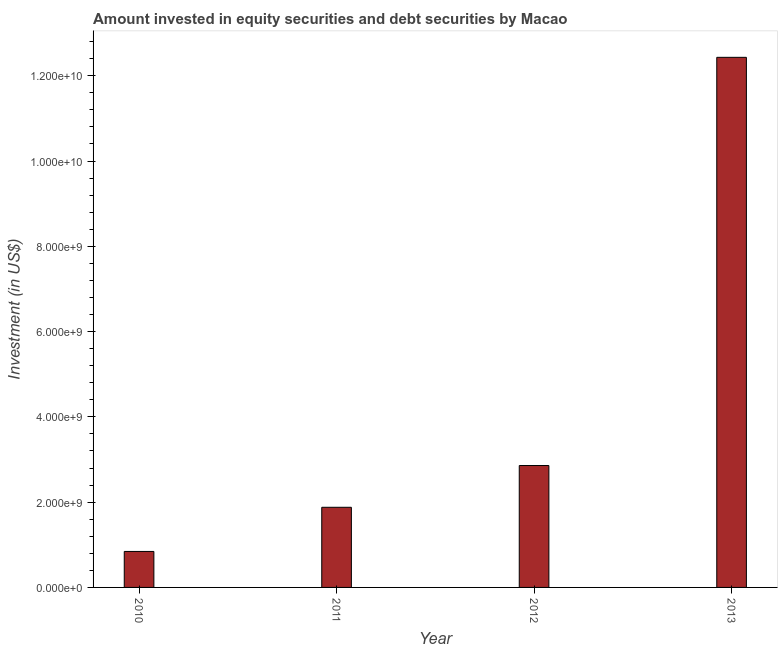Does the graph contain grids?
Ensure brevity in your answer.  No. What is the title of the graph?
Your response must be concise. Amount invested in equity securities and debt securities by Macao. What is the label or title of the Y-axis?
Provide a short and direct response. Investment (in US$). What is the portfolio investment in 2011?
Ensure brevity in your answer.  1.88e+09. Across all years, what is the maximum portfolio investment?
Your answer should be compact. 1.24e+1. Across all years, what is the minimum portfolio investment?
Ensure brevity in your answer.  8.44e+08. In which year was the portfolio investment minimum?
Provide a short and direct response. 2010. What is the sum of the portfolio investment?
Make the answer very short. 1.80e+1. What is the difference between the portfolio investment in 2012 and 2013?
Make the answer very short. -9.57e+09. What is the average portfolio investment per year?
Make the answer very short. 4.50e+09. What is the median portfolio investment?
Give a very brief answer. 2.37e+09. What is the ratio of the portfolio investment in 2010 to that in 2012?
Your answer should be compact. 0.29. Is the portfolio investment in 2012 less than that in 2013?
Your answer should be compact. Yes. Is the difference between the portfolio investment in 2011 and 2013 greater than the difference between any two years?
Your response must be concise. No. What is the difference between the highest and the second highest portfolio investment?
Offer a terse response. 9.57e+09. Is the sum of the portfolio investment in 2012 and 2013 greater than the maximum portfolio investment across all years?
Your answer should be very brief. Yes. What is the difference between the highest and the lowest portfolio investment?
Your response must be concise. 1.16e+1. Are the values on the major ticks of Y-axis written in scientific E-notation?
Provide a succinct answer. Yes. What is the Investment (in US$) of 2010?
Keep it short and to the point. 8.44e+08. What is the Investment (in US$) in 2011?
Offer a very short reply. 1.88e+09. What is the Investment (in US$) in 2012?
Your answer should be very brief. 2.86e+09. What is the Investment (in US$) in 2013?
Your response must be concise. 1.24e+1. What is the difference between the Investment (in US$) in 2010 and 2011?
Keep it short and to the point. -1.04e+09. What is the difference between the Investment (in US$) in 2010 and 2012?
Make the answer very short. -2.02e+09. What is the difference between the Investment (in US$) in 2010 and 2013?
Your response must be concise. -1.16e+1. What is the difference between the Investment (in US$) in 2011 and 2012?
Your response must be concise. -9.80e+08. What is the difference between the Investment (in US$) in 2011 and 2013?
Ensure brevity in your answer.  -1.06e+1. What is the difference between the Investment (in US$) in 2012 and 2013?
Your answer should be very brief. -9.57e+09. What is the ratio of the Investment (in US$) in 2010 to that in 2011?
Your answer should be very brief. 0.45. What is the ratio of the Investment (in US$) in 2010 to that in 2012?
Your answer should be very brief. 0.29. What is the ratio of the Investment (in US$) in 2010 to that in 2013?
Offer a terse response. 0.07. What is the ratio of the Investment (in US$) in 2011 to that in 2012?
Your response must be concise. 0.66. What is the ratio of the Investment (in US$) in 2011 to that in 2013?
Your answer should be very brief. 0.15. What is the ratio of the Investment (in US$) in 2012 to that in 2013?
Make the answer very short. 0.23. 